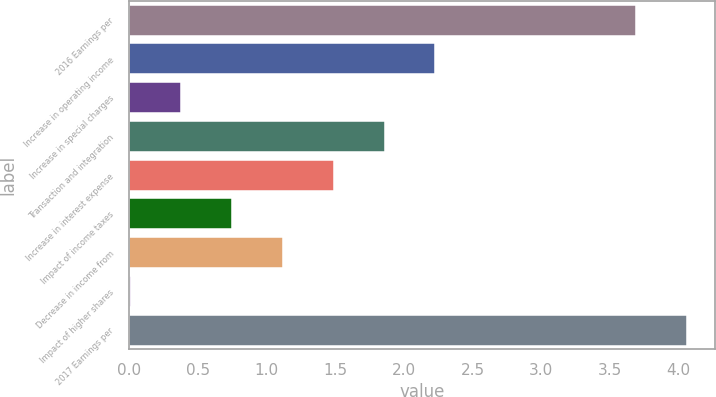Convert chart. <chart><loc_0><loc_0><loc_500><loc_500><bar_chart><fcel>2016 Earnings per<fcel>Increase in operating income<fcel>Increase in special charges<fcel>Transaction and integration<fcel>Increase in interest expense<fcel>Impact of income taxes<fcel>Decrease in income from<fcel>Impact of higher shares<fcel>2017 Earnings per<nl><fcel>3.69<fcel>2.23<fcel>0.38<fcel>1.86<fcel>1.49<fcel>0.75<fcel>1.12<fcel>0.01<fcel>4.06<nl></chart> 